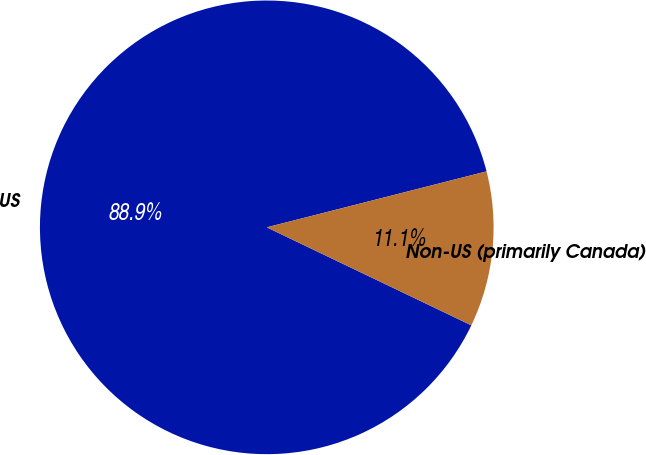Convert chart to OTSL. <chart><loc_0><loc_0><loc_500><loc_500><pie_chart><fcel>US<fcel>Non-US (primarily Canada)<nl><fcel>88.92%<fcel>11.08%<nl></chart> 